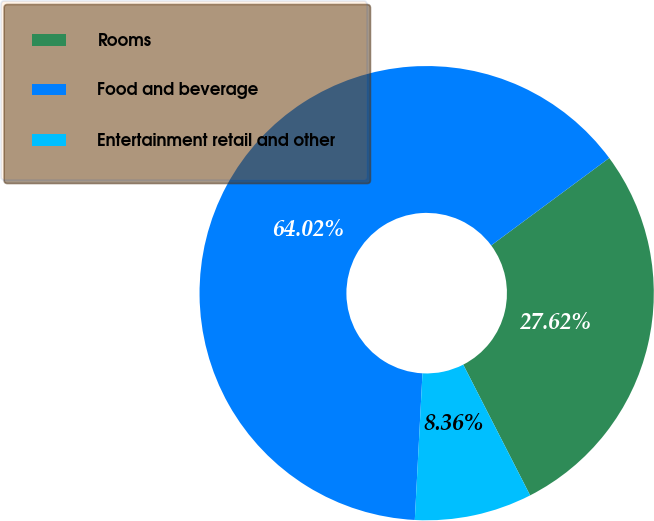Convert chart to OTSL. <chart><loc_0><loc_0><loc_500><loc_500><pie_chart><fcel>Rooms<fcel>Food and beverage<fcel>Entertainment retail and other<nl><fcel>27.62%<fcel>64.03%<fcel>8.36%<nl></chart> 